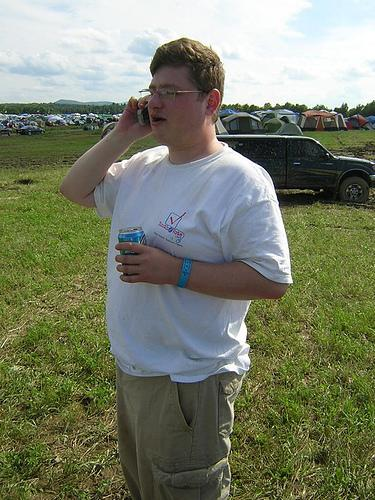What is his hairstyle?

Choices:
A) short
B) long
C) curly
D) shaved long 